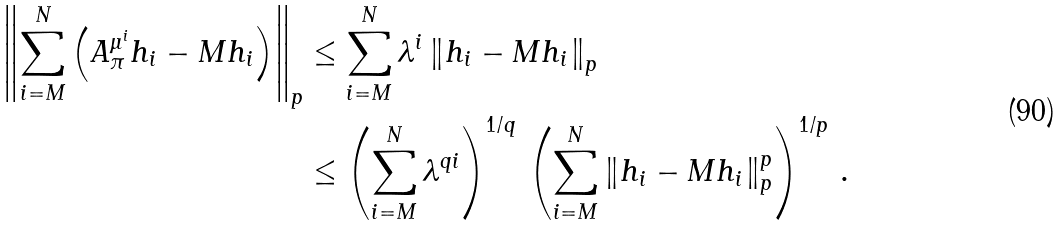Convert formula to latex. <formula><loc_0><loc_0><loc_500><loc_500>\left \| \sum _ { i = M } ^ { N } \left ( A ^ { \mu ^ { i } } _ { \pi } h _ { i } - M { h _ { i } } \right ) \right \| _ { p } & \leq \sum _ { i = M } ^ { N } \lambda ^ { i } \left \| h _ { i } - M { h _ { i } } \right \| _ { p } \\ & \leq \left ( \sum _ { i = M } ^ { N } \lambda ^ { q i } \right ) ^ { 1 / q } \, \left ( \sum _ { i = M } ^ { N } \left \| h _ { i } - M { h _ { i } } \right \| _ { p } ^ { p } \right ) ^ { 1 / p } \, .</formula> 